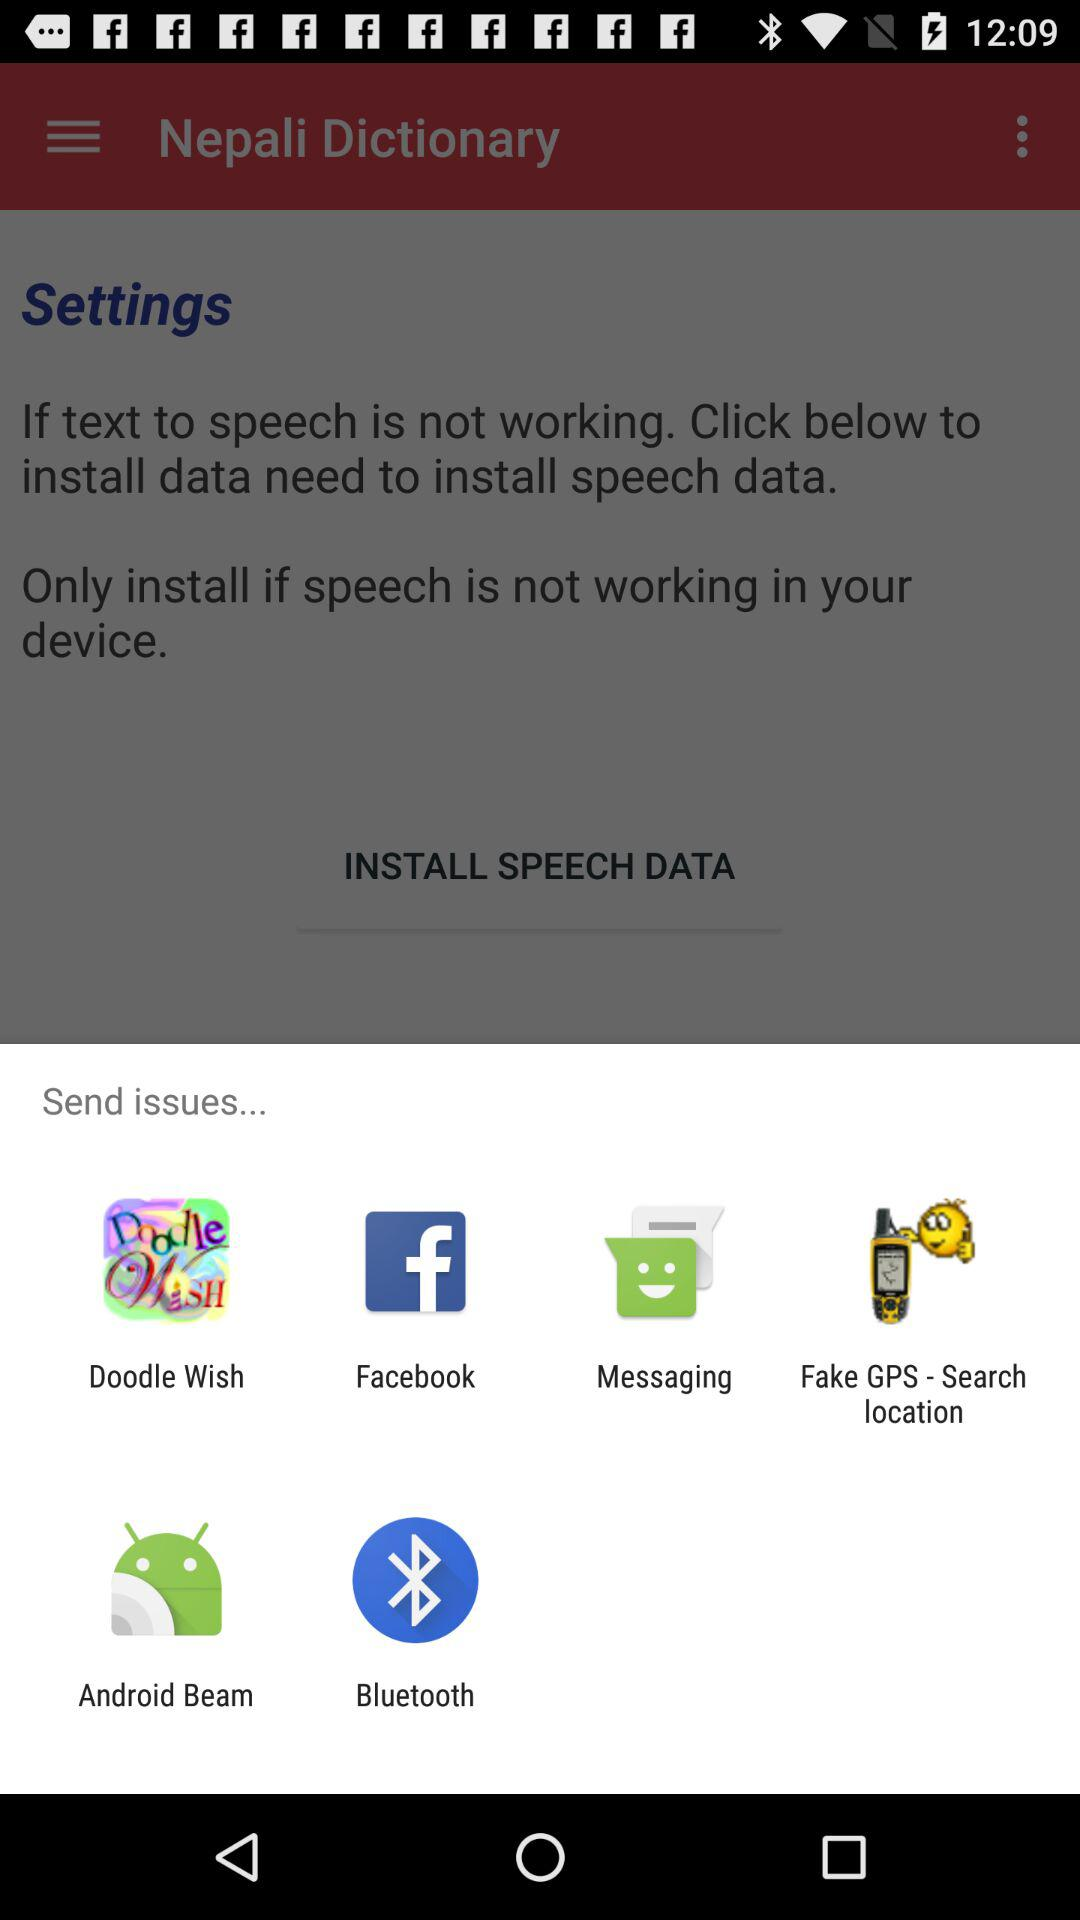What are the apps that can be used to share issues? The apps that can be used to share issues are "Doodle Wish", "Facebook", "Messaging", "Fake GPS - Search location", "Android Beam" and "Bluetooth". 